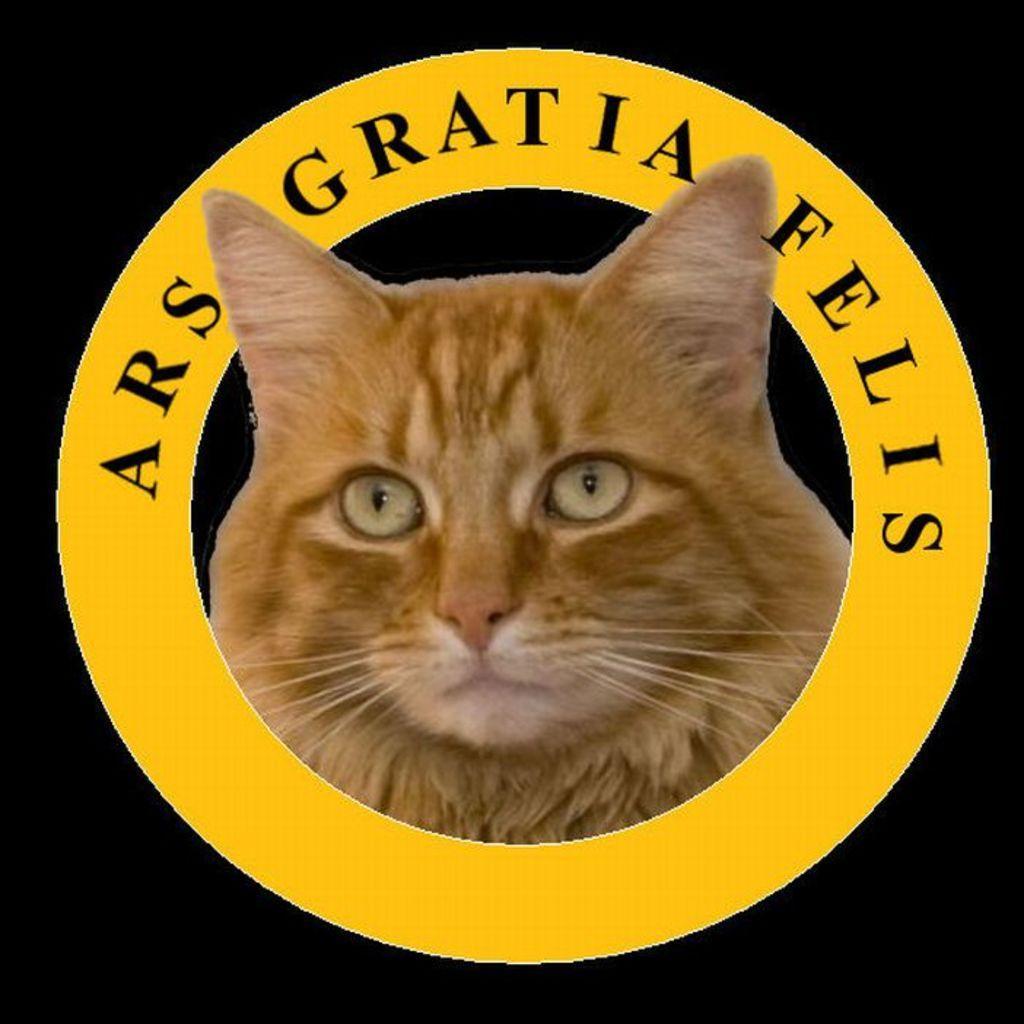In one or two sentences, can you explain what this image depicts? In this image I see a cat face over here which is of cream and brown in color and I see few words written and it is dark in the background. 